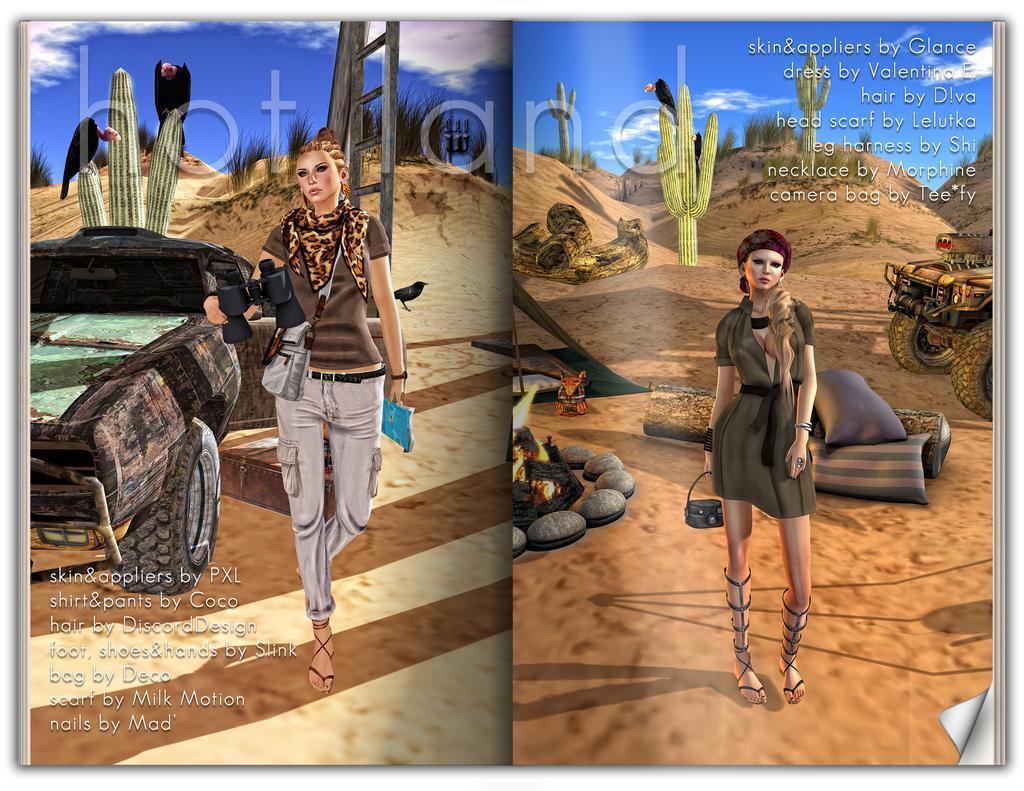Could you give a brief overview of what you see in this image? This picture is a collage of two images. I can observe two women in these two images. There is a vehicle on the left side and I can observe text on the bottom left side. I can observe another vehicle on the right side and there is some text on the top right side. In the background there are some plants and a cloudy sky in these two images. 